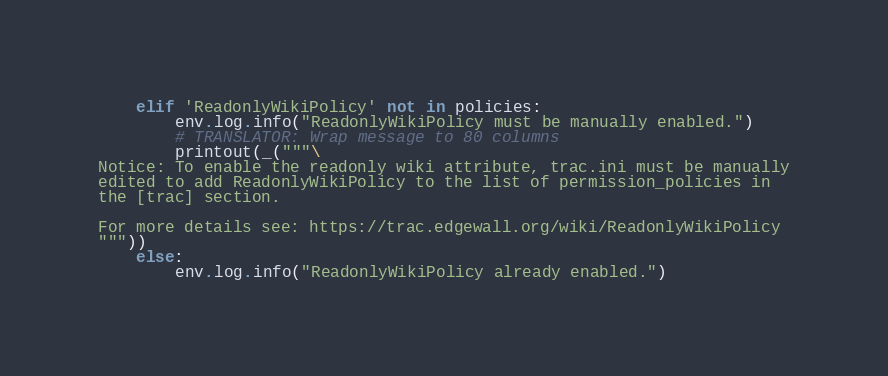<code> <loc_0><loc_0><loc_500><loc_500><_Python_>    elif 'ReadonlyWikiPolicy' not in policies:
        env.log.info("ReadonlyWikiPolicy must be manually enabled.")
        # TRANSLATOR: Wrap message to 80 columns
        printout(_("""\
Notice: To enable the readonly wiki attribute, trac.ini must be manually
edited to add ReadonlyWikiPolicy to the list of permission_policies in
the [trac] section.

For more details see: https://trac.edgewall.org/wiki/ReadonlyWikiPolicy
"""))
    else:
        env.log.info("ReadonlyWikiPolicy already enabled.")
</code> 